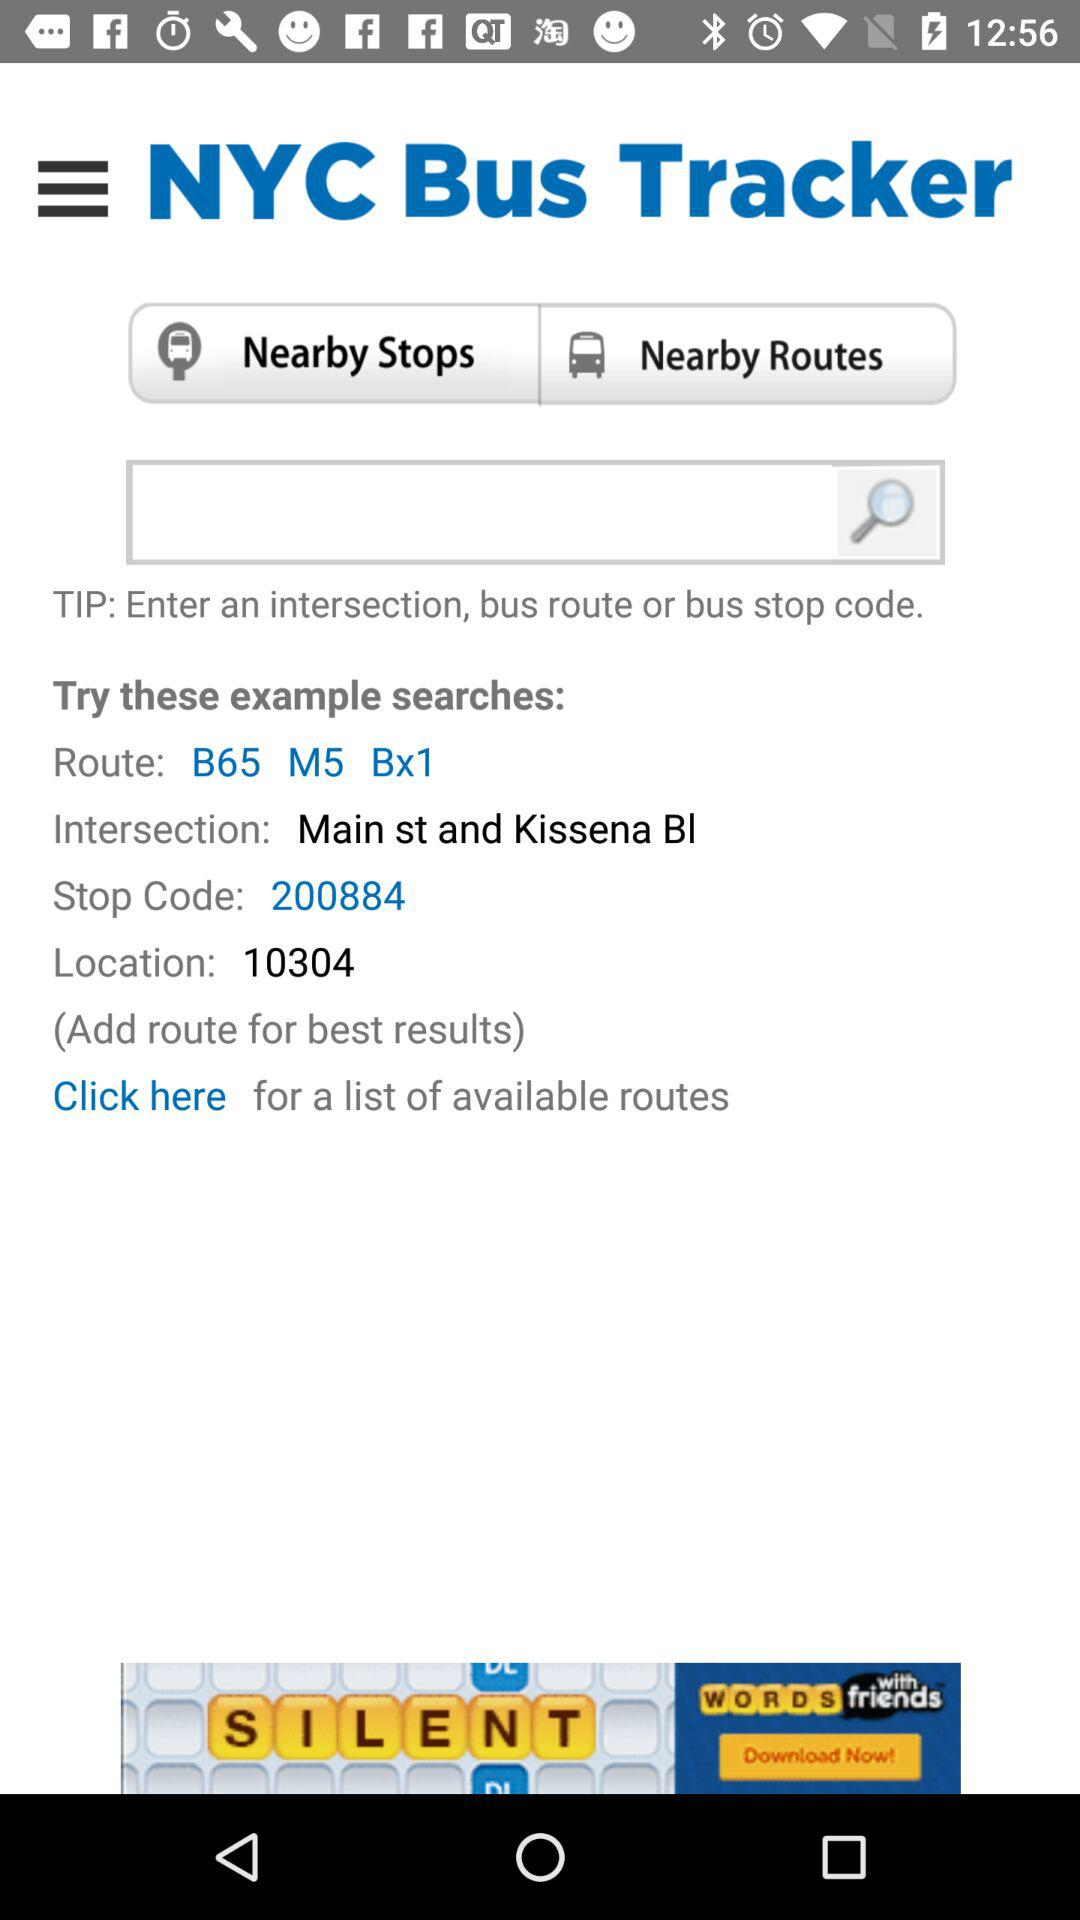What is the name of the application? The name of the application is "NYC Bus Tracker". 